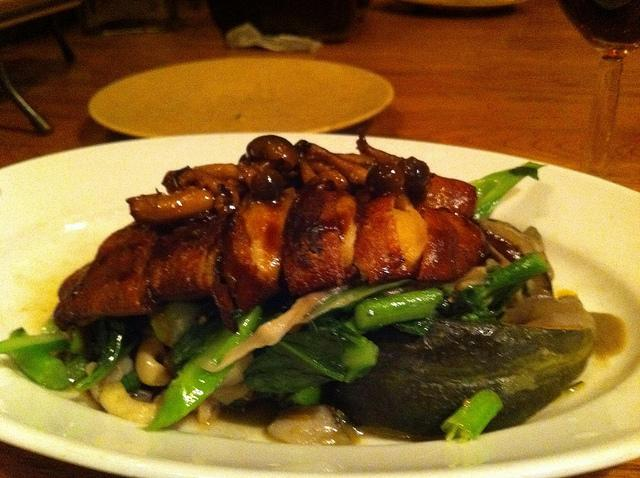What has caused the food on the plate to look shiny? oil 